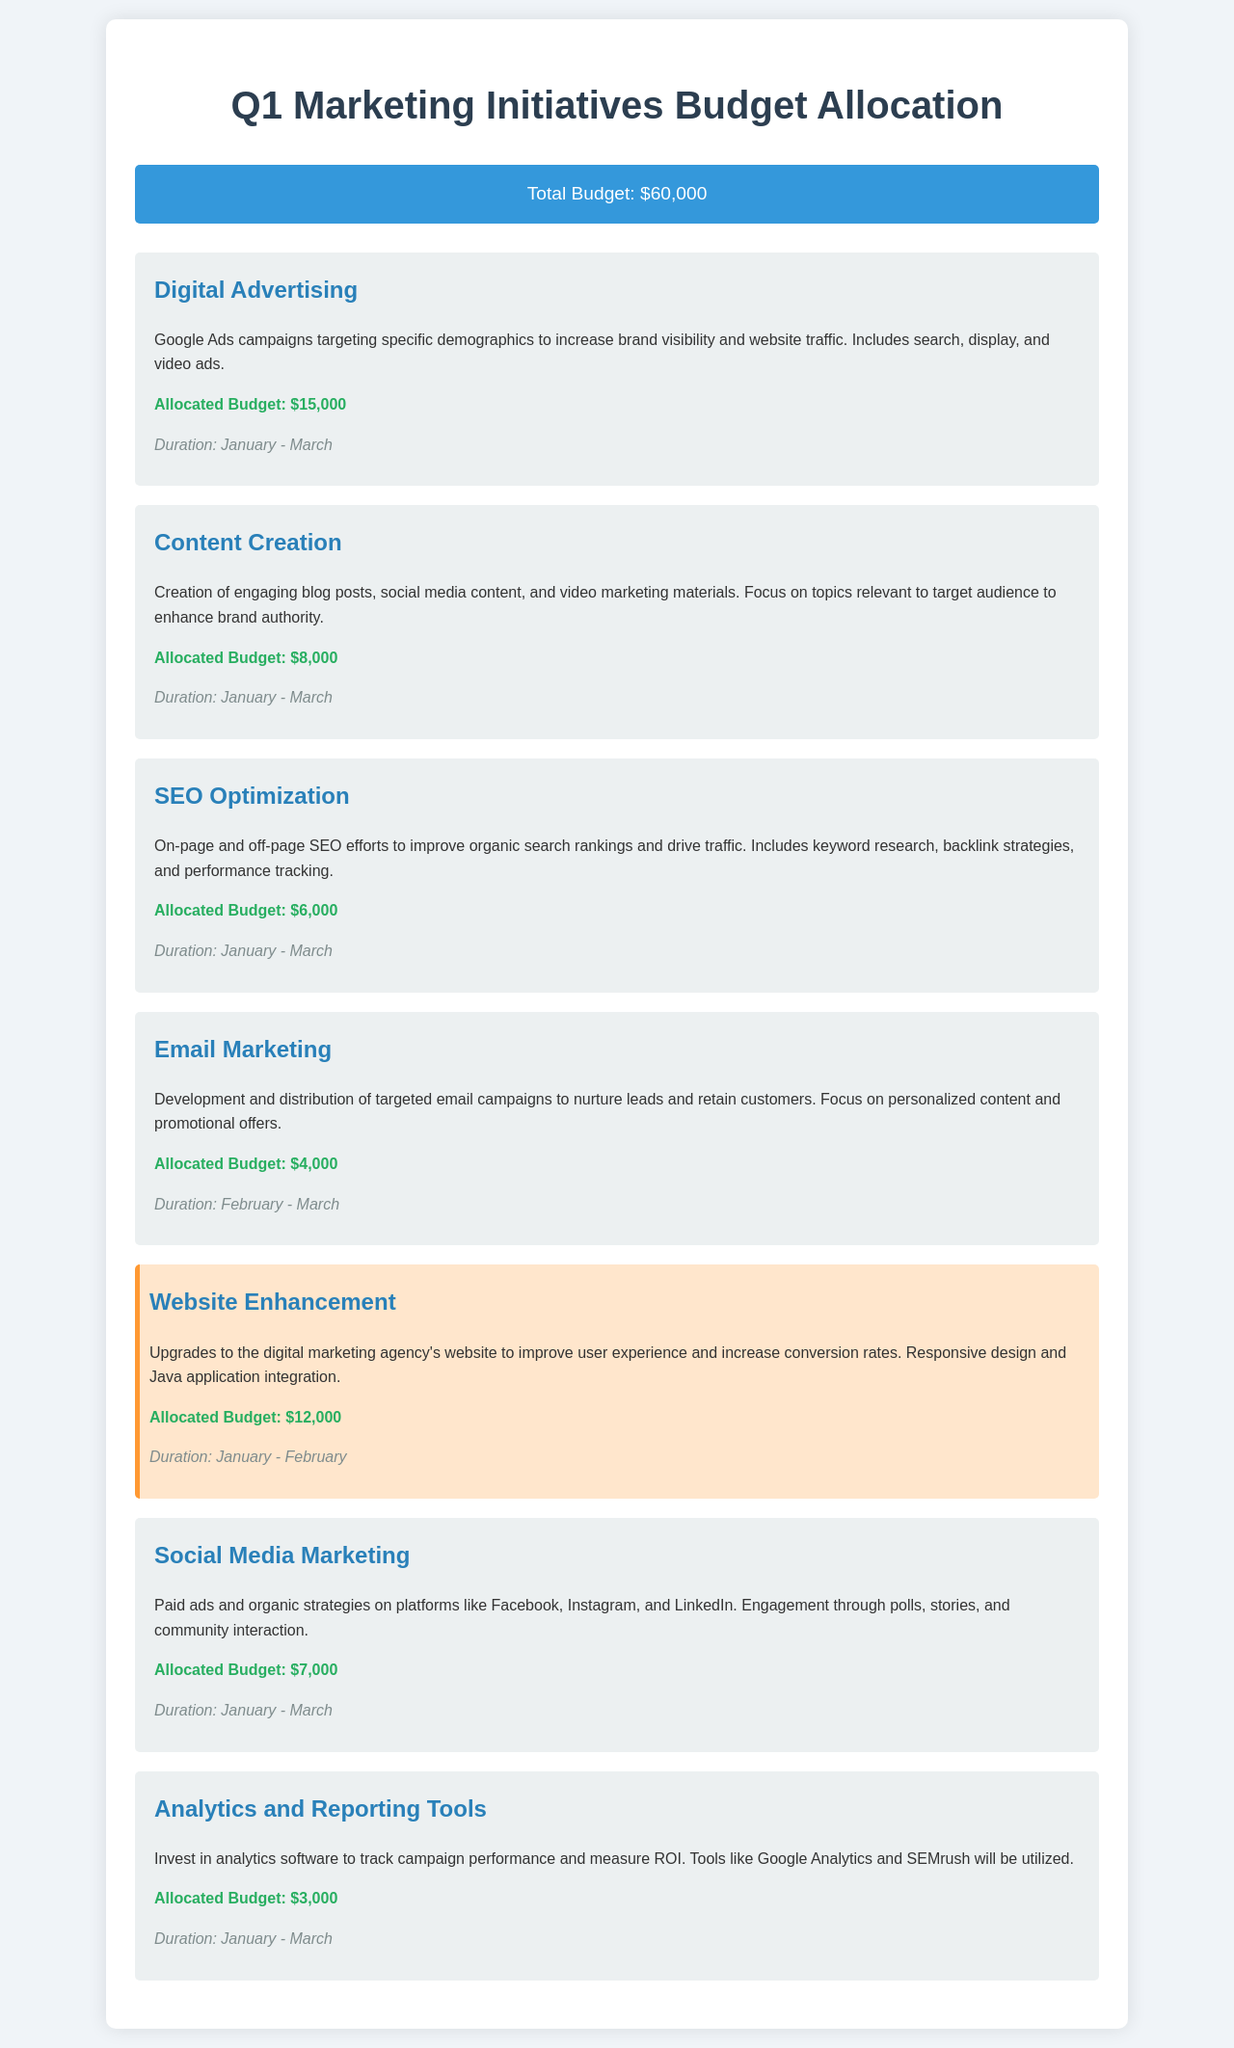What is the total budget for Q1 marketing initiatives? The total budget is stated clearly in the budget summary section of the document.
Answer: $60,000 How much is allocated for Website Enhancement? The allocated budget for Website Enhancement is specified in the initiative section.
Answer: $12,000 Which initiative has the highest allocated budget? The initiative with the highest budget can be determined by comparing the allocated amounts listed.
Answer: Digital Advertising What is the duration of the Email Marketing initiative? The duration is provided within the Email Marketing initiative description.
Answer: February - March How much is budgeted for SEO Optimization? The specific budget for SEO Optimization is directly mentioned in its section.
Answer: $6,000 Which marketing initiative is highlighted as using Java applications? The initiative that specifically mentions the use of Java applications can be found in its description.
Answer: Website Enhancement How many initiatives last from January to March? By checking the duration for each initiative, we can count the ones that fall within these months.
Answer: 5 What is the allocated budget for Analytics and Reporting Tools? The budget amount for this specific initiative is provided in its respective section.
Answer: $3,000 What percentage of the total budget is allocated to Content Creation? This can be calculated based on the allocated budget and the total budget using the figures in the document.
Answer: 13.33% 